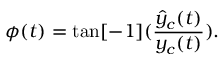<formula> <loc_0><loc_0><loc_500><loc_500>\phi ( t ) = \tan [ - 1 ] ( \frac { \hat { y } _ { c } ( t ) } { y _ { c } ( t ) } ) .</formula> 